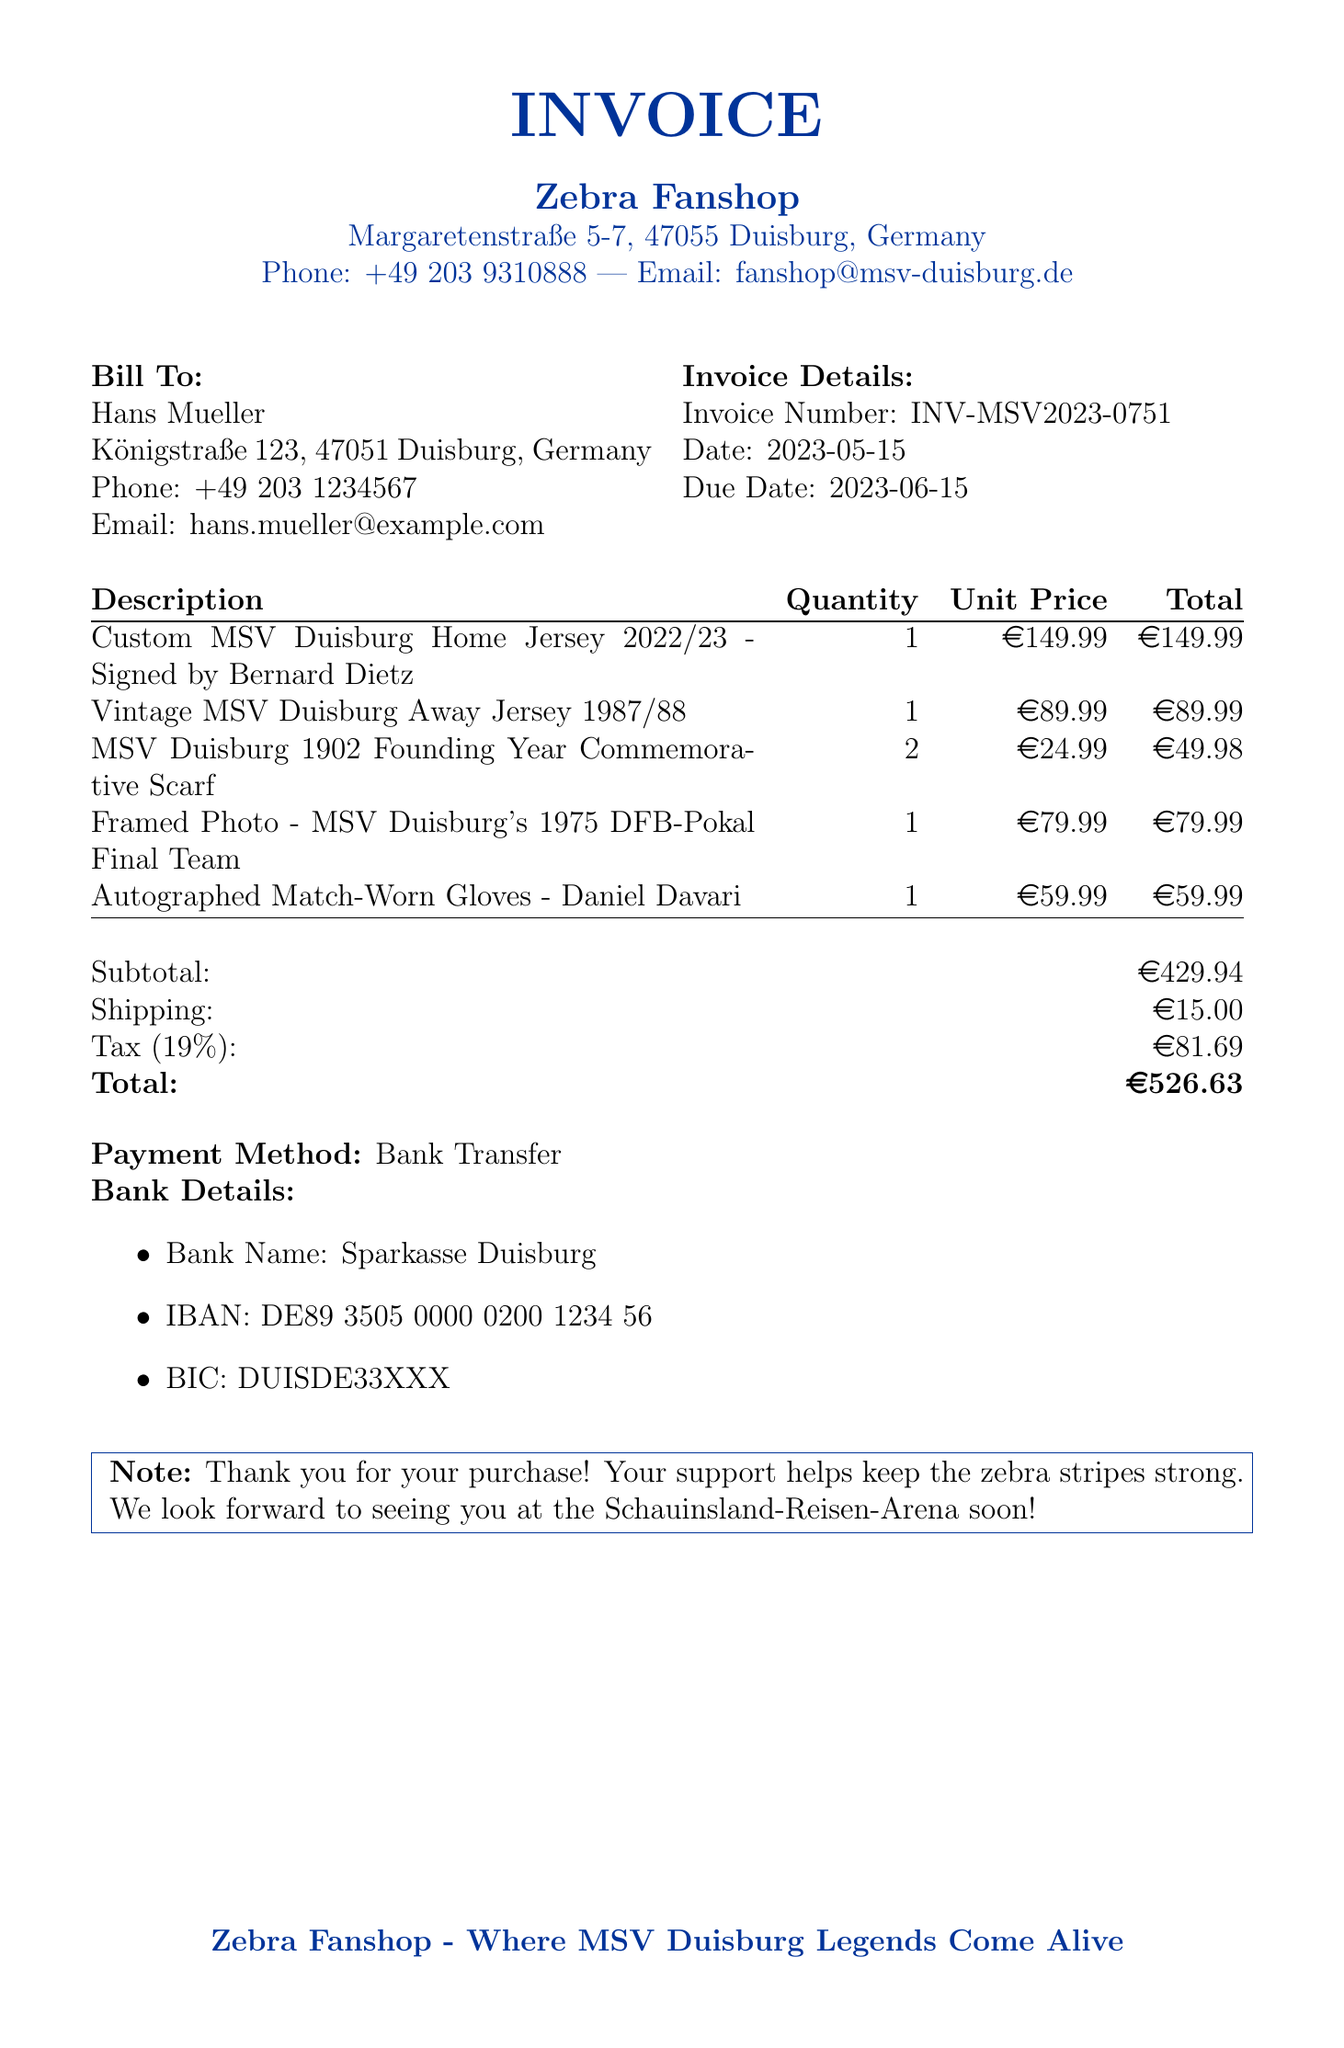What is the invoice number? The invoice number is listed at the top of the document.
Answer: INV-MSV2023-0751 Who is the seller? The seller's name and address are presented in the document.
Answer: Zebra Fanshop What is the total amount due? The total amount is calculated at the end of the invoice.
Answer: €526.63 When is the invoice due? The due date is indicated in the invoice details section.
Answer: 2023-06-15 How many Founding Year Commemorative Scarves were purchased? The quantity of scarves purchased is noted next to the description.
Answer: 2 What is the shipping cost? The shipping cost is listed under the financial summary section.
Answer: €15.00 What is the tax rate applied to the invoice? The tax rate is specified near the total calculation.
Answer: 19% Who signed the custom jersey? The name of the person who signed the jersey is included in the item description.
Answer: Bernard Dietz What payment method is accepted? The payment method is mentioned towards the end of the invoice.
Answer: Bank Transfer 